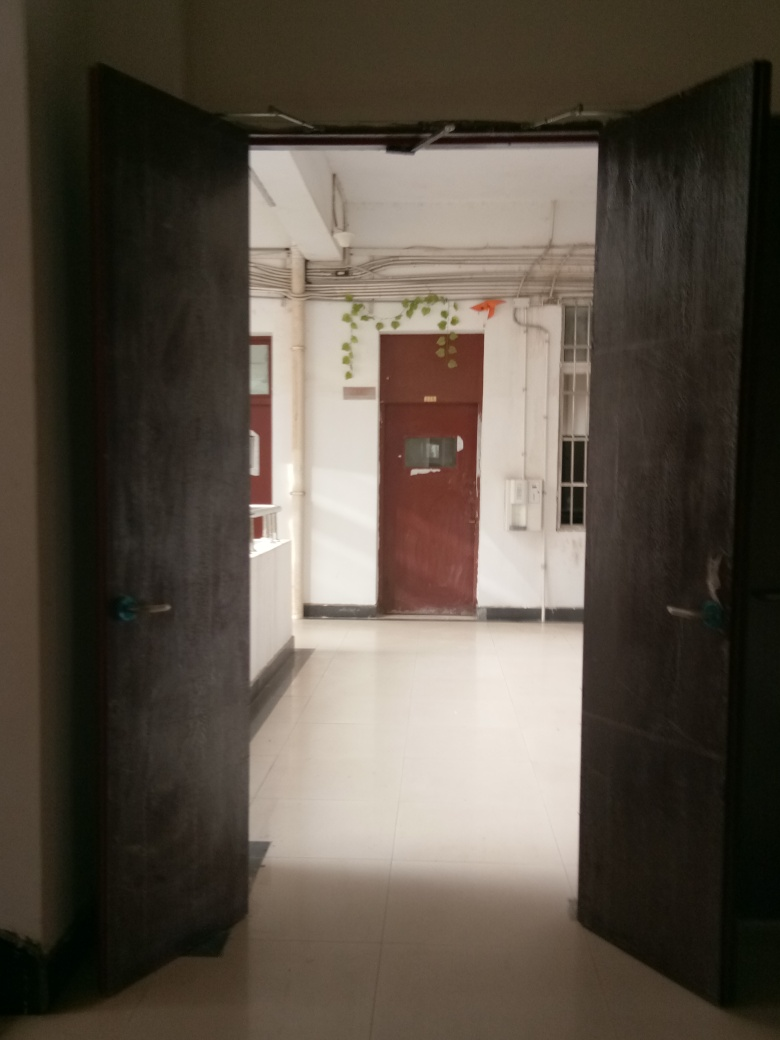Are there any signs or items that hint at the type of building this door belongs to? No explicit signs are visible that indicate the precise nature of the building. However, the practical design of the door, the corridor's simplicity, and features like the bulletin board with papers and the presence of multiple doors suggest it could be an office, a clinic, or an educational institution. 